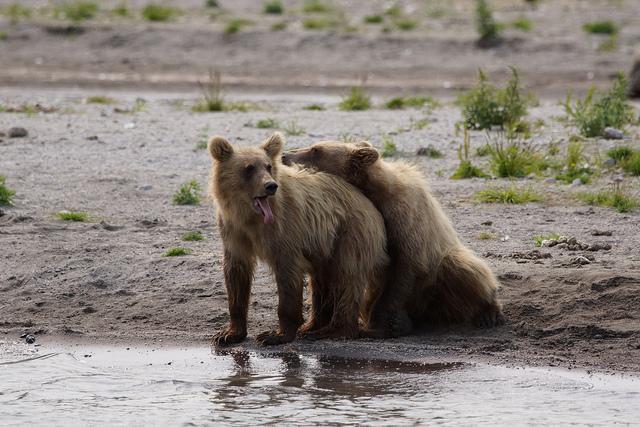How many bears are there?
Give a very brief answer. 2. 